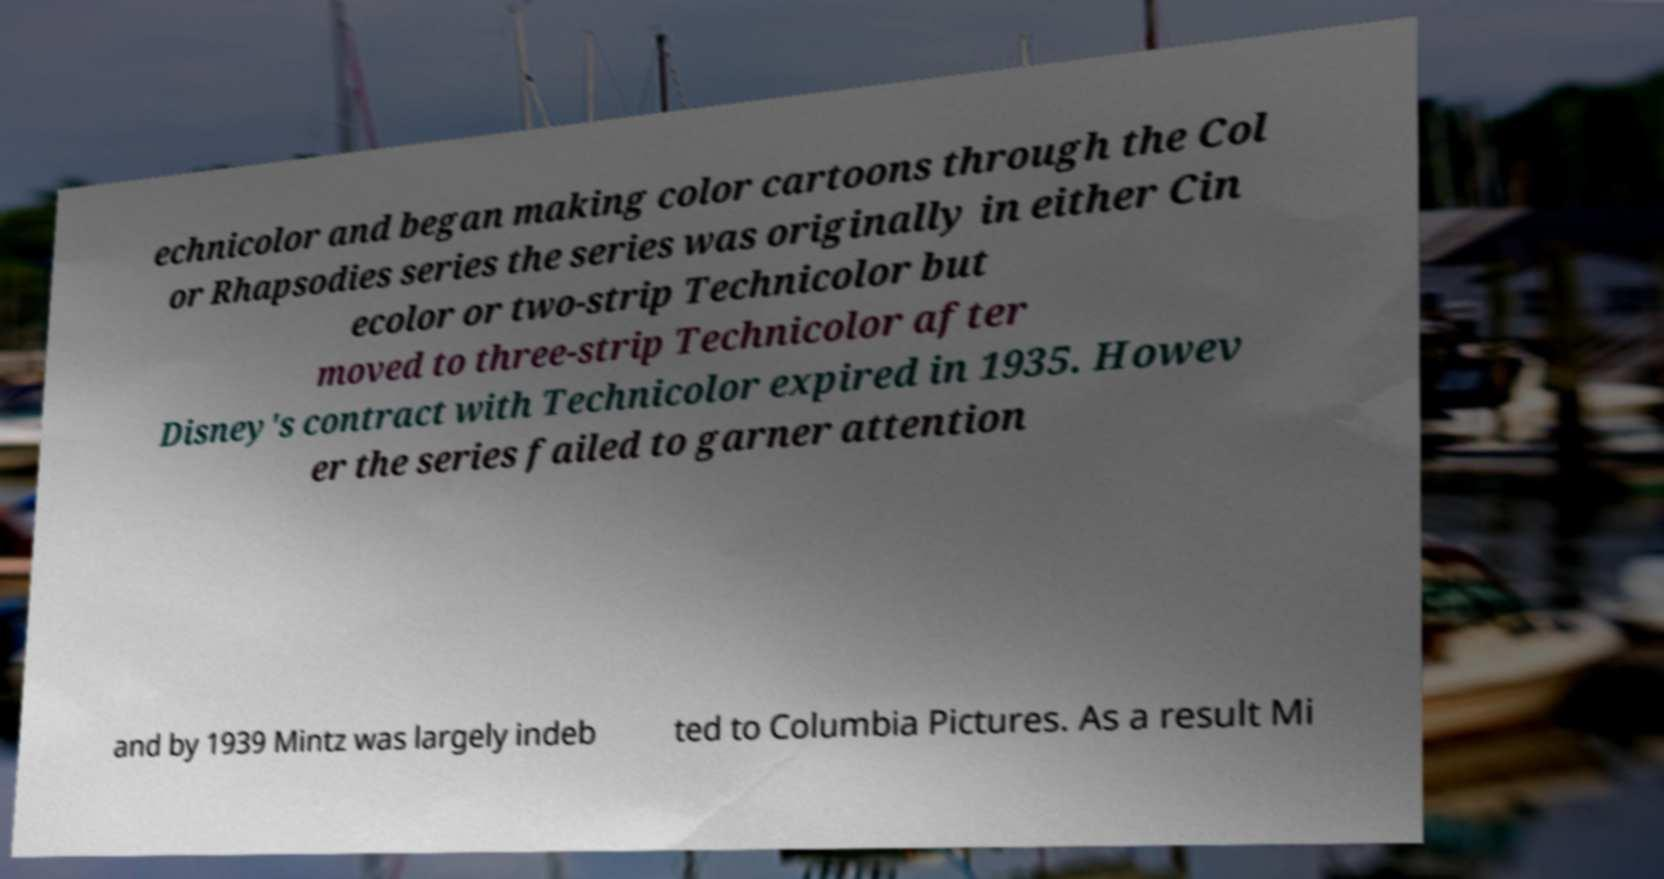Can you accurately transcribe the text from the provided image for me? echnicolor and began making color cartoons through the Col or Rhapsodies series the series was originally in either Cin ecolor or two-strip Technicolor but moved to three-strip Technicolor after Disney's contract with Technicolor expired in 1935. Howev er the series failed to garner attention and by 1939 Mintz was largely indeb ted to Columbia Pictures. As a result Mi 